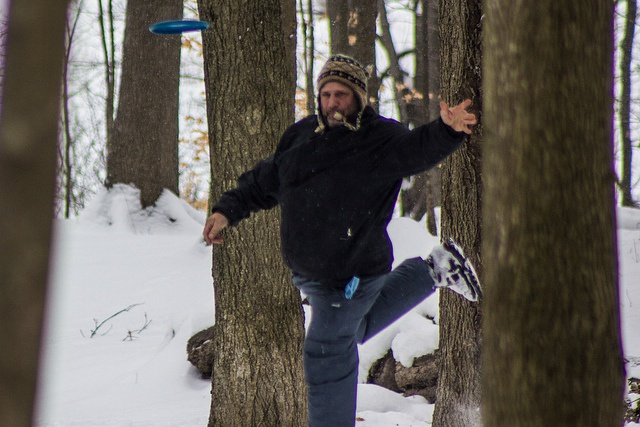Describe the objects in this image and their specific colors. I can see people in darkgray, black, and gray tones and frisbee in darkgray, navy, blue, and teal tones in this image. 